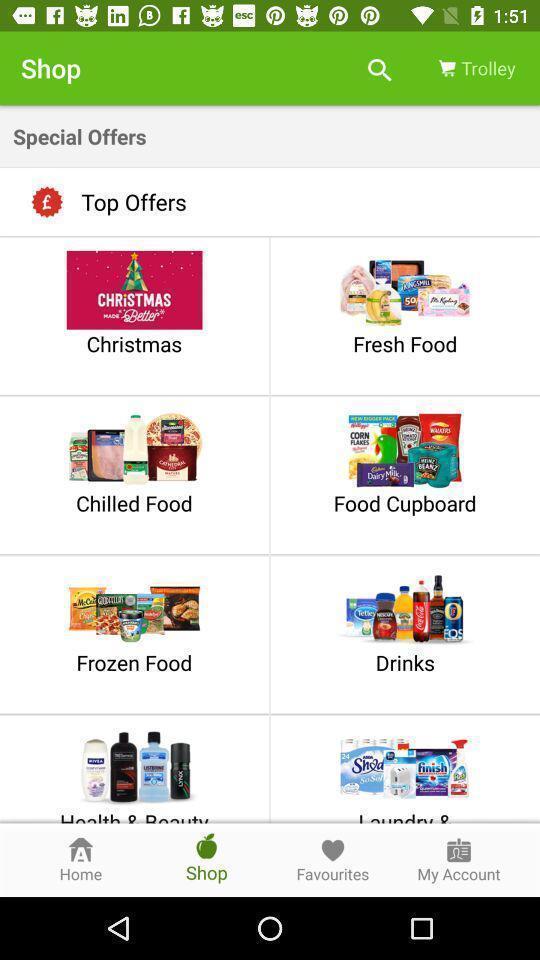Explain the elements present in this screenshot. Shopping page displayed different categories and other options. 